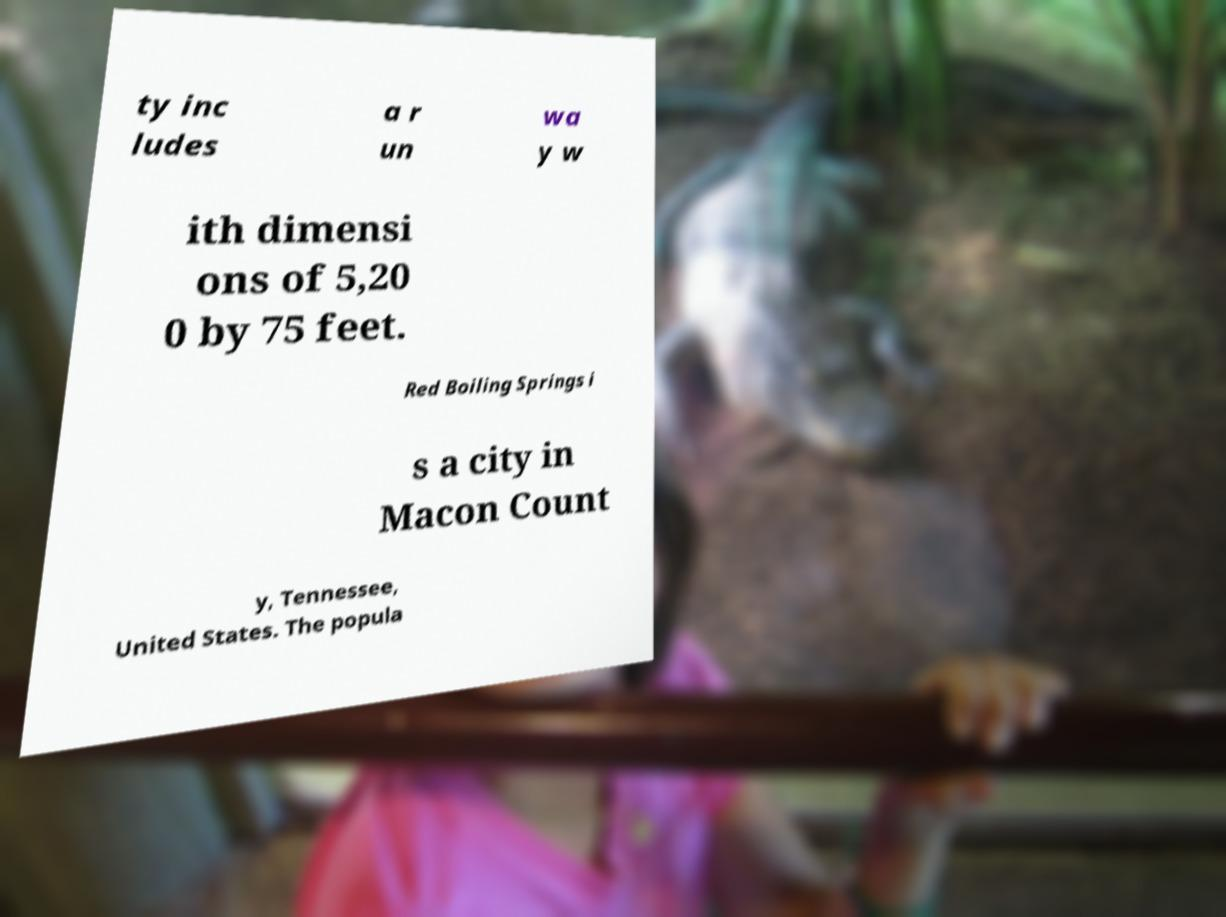Please read and relay the text visible in this image. What does it say? ty inc ludes a r un wa y w ith dimensi ons of 5,20 0 by 75 feet. Red Boiling Springs i s a city in Macon Count y, Tennessee, United States. The popula 